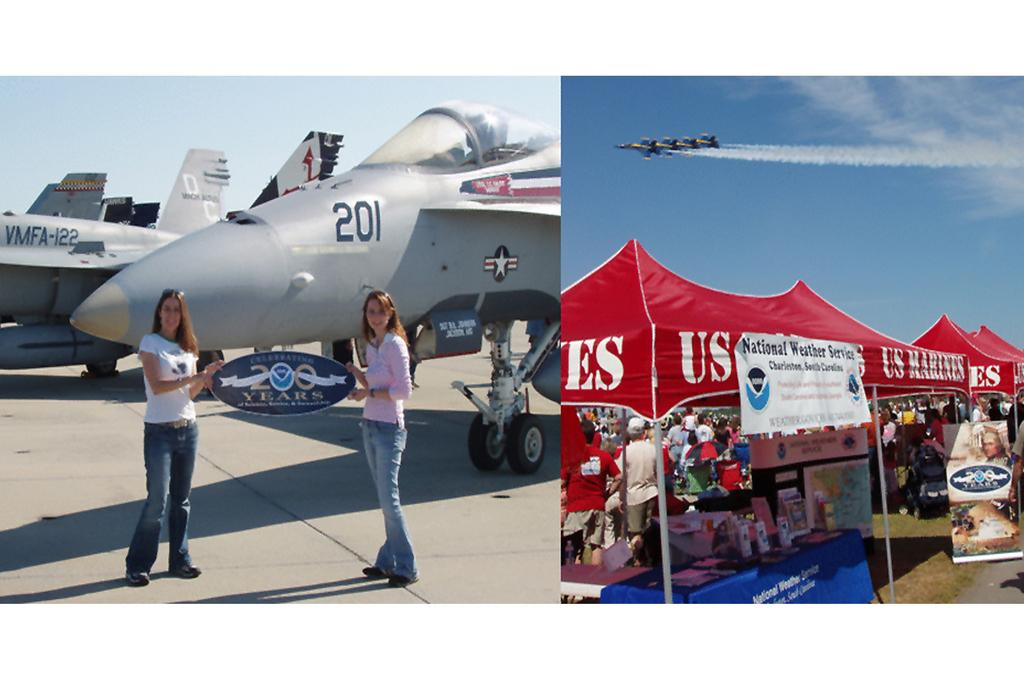<image>
Summarize the visual content of the image. Two girls hold a sign up in front of an airplane that reads "celebrating 200 years" 